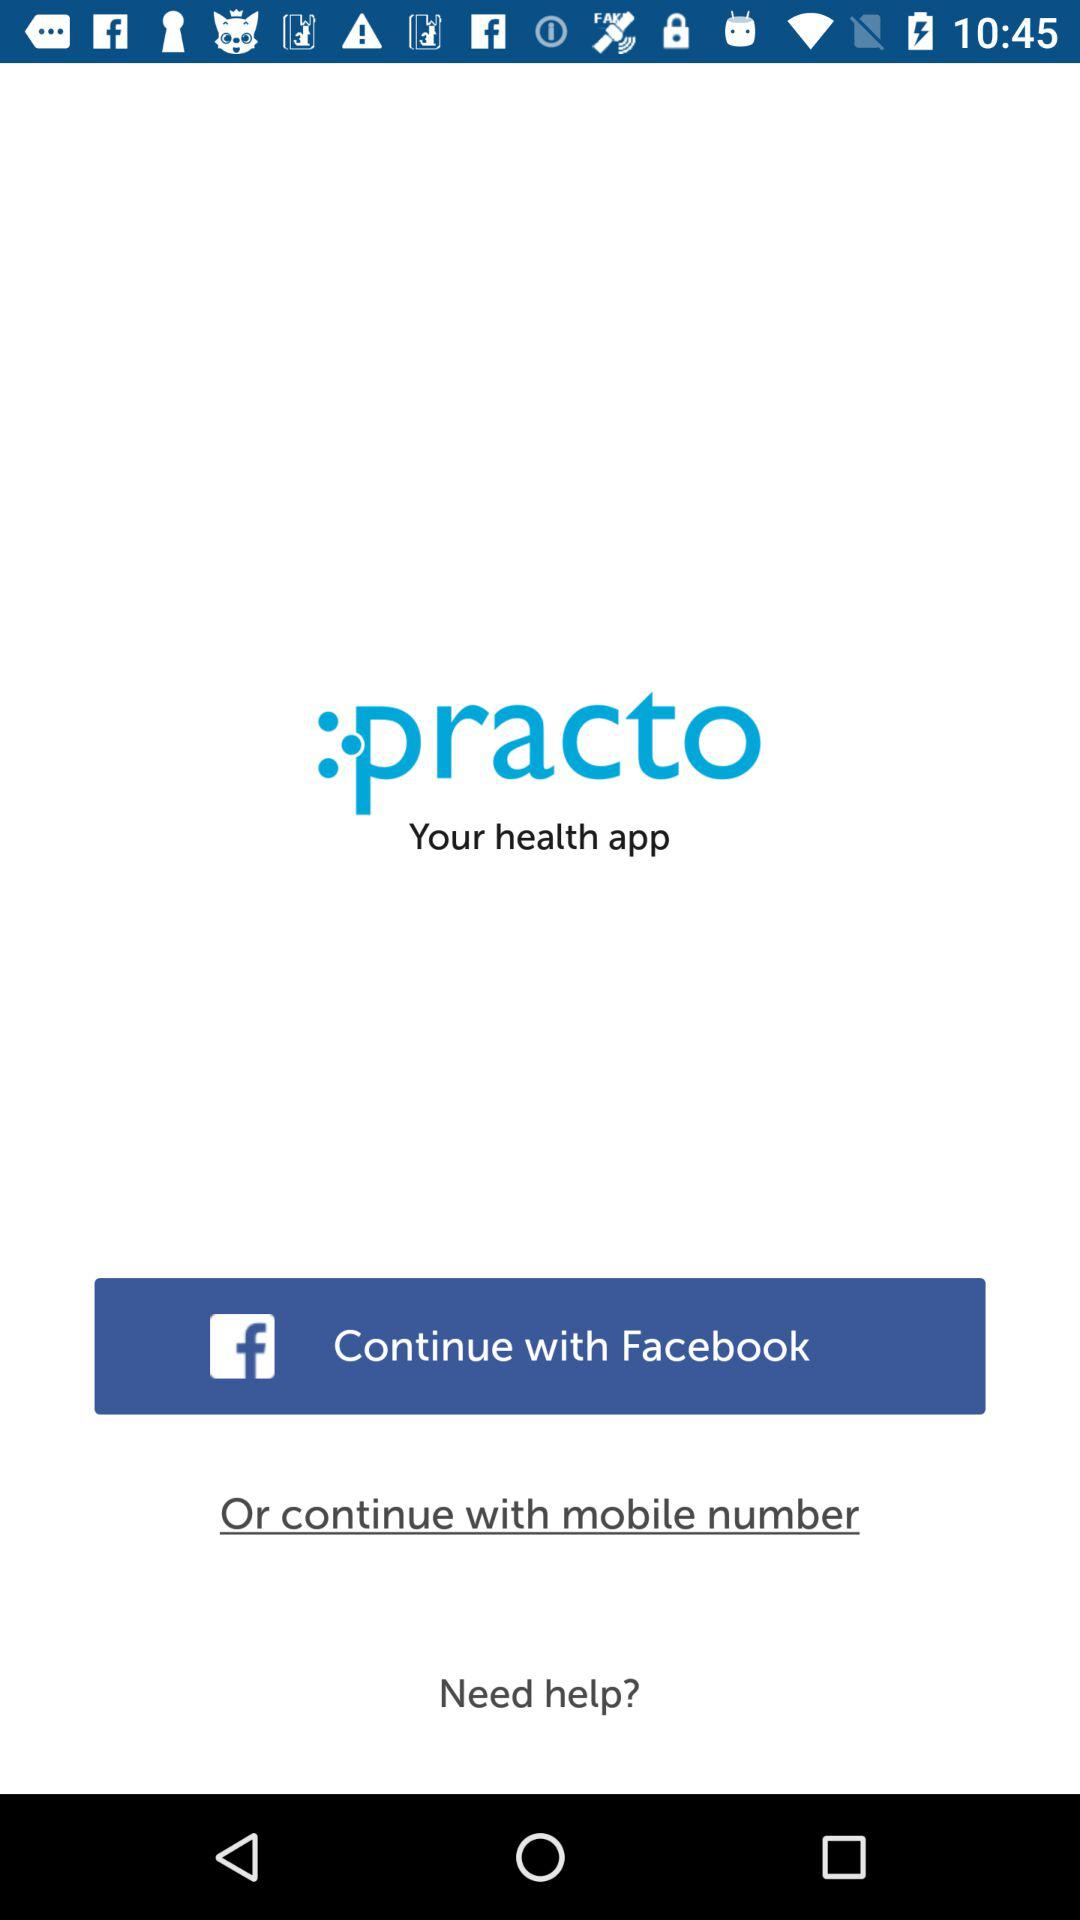What is the application name? The application name is "practo". 